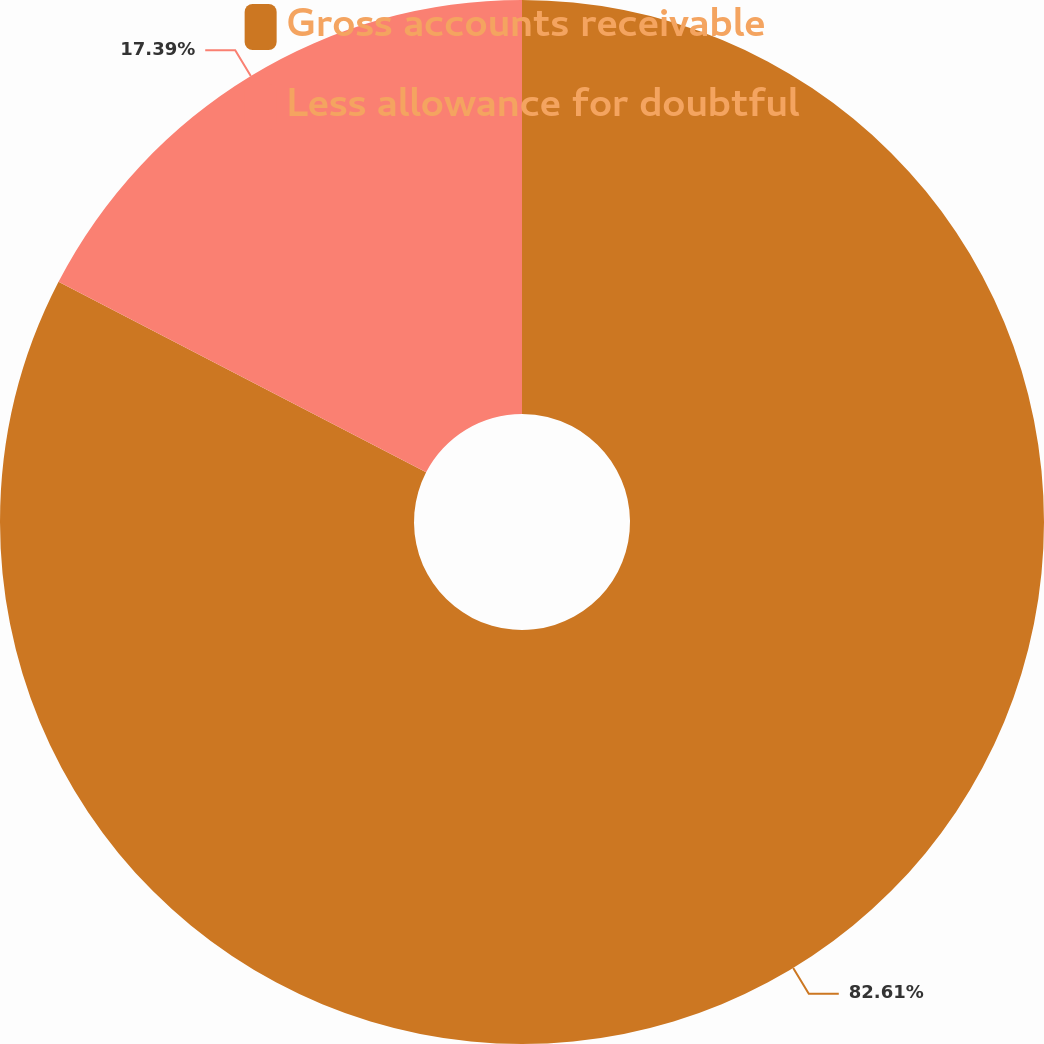Convert chart. <chart><loc_0><loc_0><loc_500><loc_500><pie_chart><fcel>Gross accounts receivable<fcel>Less allowance for doubtful<nl><fcel>82.61%<fcel>17.39%<nl></chart> 